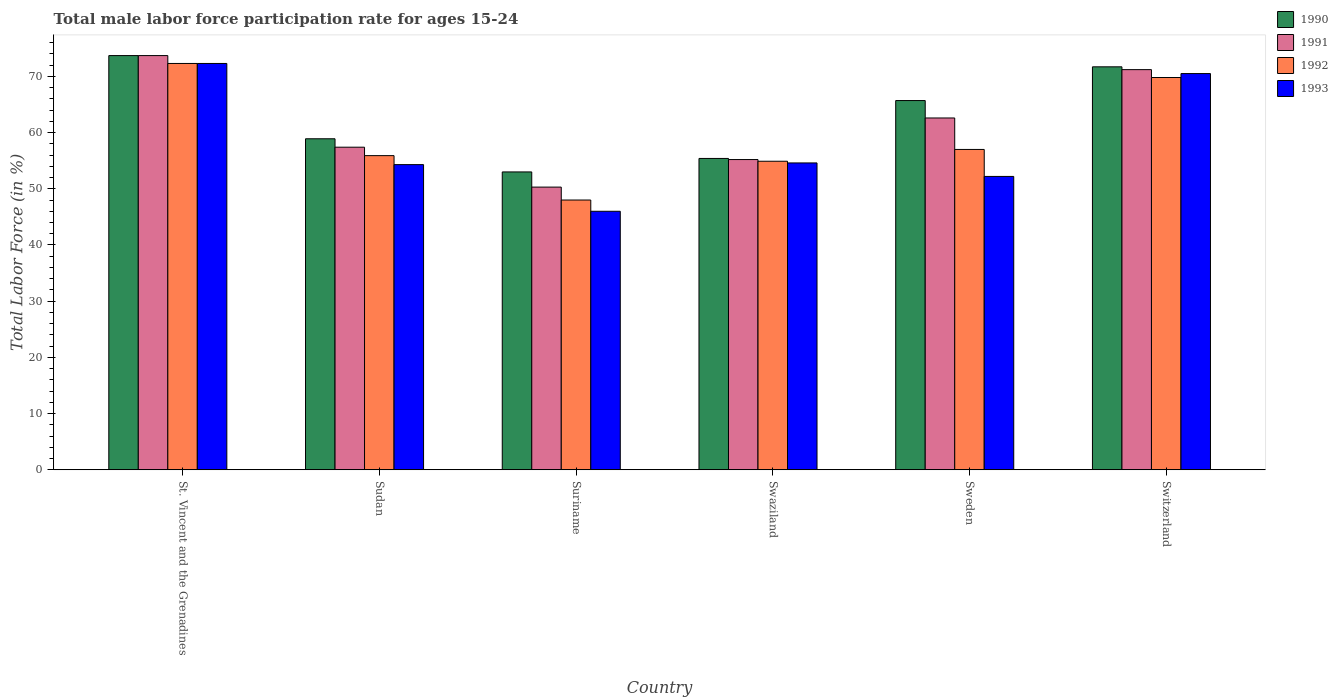Are the number of bars on each tick of the X-axis equal?
Your answer should be very brief. Yes. How many bars are there on the 4th tick from the right?
Your answer should be very brief. 4. What is the label of the 5th group of bars from the left?
Your response must be concise. Sweden. In how many cases, is the number of bars for a given country not equal to the number of legend labels?
Your answer should be compact. 0. What is the male labor force participation rate in 1991 in Switzerland?
Give a very brief answer. 71.2. Across all countries, what is the maximum male labor force participation rate in 1992?
Keep it short and to the point. 72.3. Across all countries, what is the minimum male labor force participation rate in 1993?
Ensure brevity in your answer.  46. In which country was the male labor force participation rate in 1991 maximum?
Keep it short and to the point. St. Vincent and the Grenadines. In which country was the male labor force participation rate in 1992 minimum?
Your answer should be very brief. Suriname. What is the total male labor force participation rate in 1993 in the graph?
Provide a short and direct response. 349.9. What is the difference between the male labor force participation rate in 1993 in Suriname and that in Sweden?
Offer a terse response. -6.2. What is the average male labor force participation rate in 1992 per country?
Your answer should be compact. 59.65. What is the difference between the male labor force participation rate of/in 1993 and male labor force participation rate of/in 1990 in Sudan?
Offer a terse response. -4.6. In how many countries, is the male labor force participation rate in 1991 greater than 56 %?
Give a very brief answer. 4. What is the ratio of the male labor force participation rate in 1990 in Suriname to that in Sweden?
Your answer should be very brief. 0.81. What is the difference between the highest and the lowest male labor force participation rate in 1991?
Your answer should be compact. 23.4. In how many countries, is the male labor force participation rate in 1991 greater than the average male labor force participation rate in 1991 taken over all countries?
Give a very brief answer. 3. Is the sum of the male labor force participation rate in 1991 in Sudan and Suriname greater than the maximum male labor force participation rate in 1990 across all countries?
Keep it short and to the point. Yes. What does the 4th bar from the left in Sweden represents?
Offer a very short reply. 1993. How many bars are there?
Offer a terse response. 24. How many countries are there in the graph?
Offer a terse response. 6. What is the difference between two consecutive major ticks on the Y-axis?
Give a very brief answer. 10. Are the values on the major ticks of Y-axis written in scientific E-notation?
Make the answer very short. No. Where does the legend appear in the graph?
Offer a terse response. Top right. What is the title of the graph?
Your answer should be compact. Total male labor force participation rate for ages 15-24. What is the Total Labor Force (in %) of 1990 in St. Vincent and the Grenadines?
Give a very brief answer. 73.7. What is the Total Labor Force (in %) of 1991 in St. Vincent and the Grenadines?
Your answer should be compact. 73.7. What is the Total Labor Force (in %) of 1992 in St. Vincent and the Grenadines?
Provide a succinct answer. 72.3. What is the Total Labor Force (in %) in 1993 in St. Vincent and the Grenadines?
Provide a succinct answer. 72.3. What is the Total Labor Force (in %) of 1990 in Sudan?
Provide a succinct answer. 58.9. What is the Total Labor Force (in %) of 1991 in Sudan?
Offer a very short reply. 57.4. What is the Total Labor Force (in %) in 1992 in Sudan?
Your response must be concise. 55.9. What is the Total Labor Force (in %) of 1993 in Sudan?
Your answer should be compact. 54.3. What is the Total Labor Force (in %) in 1991 in Suriname?
Your response must be concise. 50.3. What is the Total Labor Force (in %) of 1993 in Suriname?
Provide a succinct answer. 46. What is the Total Labor Force (in %) of 1990 in Swaziland?
Keep it short and to the point. 55.4. What is the Total Labor Force (in %) in 1991 in Swaziland?
Give a very brief answer. 55.2. What is the Total Labor Force (in %) in 1992 in Swaziland?
Make the answer very short. 54.9. What is the Total Labor Force (in %) in 1993 in Swaziland?
Your answer should be very brief. 54.6. What is the Total Labor Force (in %) in 1990 in Sweden?
Your answer should be compact. 65.7. What is the Total Labor Force (in %) of 1991 in Sweden?
Your answer should be compact. 62.6. What is the Total Labor Force (in %) in 1993 in Sweden?
Your answer should be very brief. 52.2. What is the Total Labor Force (in %) in 1990 in Switzerland?
Provide a succinct answer. 71.7. What is the Total Labor Force (in %) of 1991 in Switzerland?
Offer a terse response. 71.2. What is the Total Labor Force (in %) in 1992 in Switzerland?
Your response must be concise. 69.8. What is the Total Labor Force (in %) of 1993 in Switzerland?
Your answer should be compact. 70.5. Across all countries, what is the maximum Total Labor Force (in %) of 1990?
Ensure brevity in your answer.  73.7. Across all countries, what is the maximum Total Labor Force (in %) in 1991?
Offer a very short reply. 73.7. Across all countries, what is the maximum Total Labor Force (in %) in 1992?
Keep it short and to the point. 72.3. Across all countries, what is the maximum Total Labor Force (in %) of 1993?
Ensure brevity in your answer.  72.3. Across all countries, what is the minimum Total Labor Force (in %) in 1990?
Keep it short and to the point. 53. Across all countries, what is the minimum Total Labor Force (in %) in 1991?
Your answer should be compact. 50.3. What is the total Total Labor Force (in %) of 1990 in the graph?
Keep it short and to the point. 378.4. What is the total Total Labor Force (in %) in 1991 in the graph?
Your answer should be compact. 370.4. What is the total Total Labor Force (in %) in 1992 in the graph?
Give a very brief answer. 357.9. What is the total Total Labor Force (in %) of 1993 in the graph?
Give a very brief answer. 349.9. What is the difference between the Total Labor Force (in %) in 1990 in St. Vincent and the Grenadines and that in Sudan?
Make the answer very short. 14.8. What is the difference between the Total Labor Force (in %) in 1992 in St. Vincent and the Grenadines and that in Sudan?
Your answer should be very brief. 16.4. What is the difference between the Total Labor Force (in %) in 1990 in St. Vincent and the Grenadines and that in Suriname?
Provide a short and direct response. 20.7. What is the difference between the Total Labor Force (in %) in 1991 in St. Vincent and the Grenadines and that in Suriname?
Offer a very short reply. 23.4. What is the difference between the Total Labor Force (in %) of 1992 in St. Vincent and the Grenadines and that in Suriname?
Provide a succinct answer. 24.3. What is the difference between the Total Labor Force (in %) in 1993 in St. Vincent and the Grenadines and that in Suriname?
Ensure brevity in your answer.  26.3. What is the difference between the Total Labor Force (in %) in 1991 in St. Vincent and the Grenadines and that in Swaziland?
Provide a short and direct response. 18.5. What is the difference between the Total Labor Force (in %) of 1992 in St. Vincent and the Grenadines and that in Swaziland?
Keep it short and to the point. 17.4. What is the difference between the Total Labor Force (in %) in 1993 in St. Vincent and the Grenadines and that in Sweden?
Your answer should be very brief. 20.1. What is the difference between the Total Labor Force (in %) of 1991 in St. Vincent and the Grenadines and that in Switzerland?
Offer a terse response. 2.5. What is the difference between the Total Labor Force (in %) of 1992 in St. Vincent and the Grenadines and that in Switzerland?
Offer a terse response. 2.5. What is the difference between the Total Labor Force (in %) of 1991 in Sudan and that in Suriname?
Offer a terse response. 7.1. What is the difference between the Total Labor Force (in %) of 1993 in Sudan and that in Suriname?
Give a very brief answer. 8.3. What is the difference between the Total Labor Force (in %) in 1991 in Sudan and that in Swaziland?
Give a very brief answer. 2.2. What is the difference between the Total Labor Force (in %) of 1990 in Sudan and that in Sweden?
Offer a terse response. -6.8. What is the difference between the Total Labor Force (in %) of 1992 in Sudan and that in Sweden?
Ensure brevity in your answer.  -1.1. What is the difference between the Total Labor Force (in %) of 1993 in Sudan and that in Sweden?
Give a very brief answer. 2.1. What is the difference between the Total Labor Force (in %) in 1992 in Sudan and that in Switzerland?
Provide a succinct answer. -13.9. What is the difference between the Total Labor Force (in %) of 1993 in Sudan and that in Switzerland?
Provide a succinct answer. -16.2. What is the difference between the Total Labor Force (in %) in 1990 in Suriname and that in Swaziland?
Offer a terse response. -2.4. What is the difference between the Total Labor Force (in %) in 1992 in Suriname and that in Swaziland?
Your answer should be very brief. -6.9. What is the difference between the Total Labor Force (in %) of 1990 in Suriname and that in Sweden?
Ensure brevity in your answer.  -12.7. What is the difference between the Total Labor Force (in %) of 1992 in Suriname and that in Sweden?
Give a very brief answer. -9. What is the difference between the Total Labor Force (in %) in 1993 in Suriname and that in Sweden?
Keep it short and to the point. -6.2. What is the difference between the Total Labor Force (in %) of 1990 in Suriname and that in Switzerland?
Provide a succinct answer. -18.7. What is the difference between the Total Labor Force (in %) of 1991 in Suriname and that in Switzerland?
Provide a succinct answer. -20.9. What is the difference between the Total Labor Force (in %) in 1992 in Suriname and that in Switzerland?
Provide a succinct answer. -21.8. What is the difference between the Total Labor Force (in %) of 1993 in Suriname and that in Switzerland?
Offer a very short reply. -24.5. What is the difference between the Total Labor Force (in %) in 1992 in Swaziland and that in Sweden?
Give a very brief answer. -2.1. What is the difference between the Total Labor Force (in %) in 1990 in Swaziland and that in Switzerland?
Make the answer very short. -16.3. What is the difference between the Total Labor Force (in %) in 1991 in Swaziland and that in Switzerland?
Your response must be concise. -16. What is the difference between the Total Labor Force (in %) in 1992 in Swaziland and that in Switzerland?
Offer a very short reply. -14.9. What is the difference between the Total Labor Force (in %) in 1993 in Swaziland and that in Switzerland?
Ensure brevity in your answer.  -15.9. What is the difference between the Total Labor Force (in %) in 1991 in Sweden and that in Switzerland?
Offer a very short reply. -8.6. What is the difference between the Total Labor Force (in %) of 1993 in Sweden and that in Switzerland?
Ensure brevity in your answer.  -18.3. What is the difference between the Total Labor Force (in %) of 1992 in St. Vincent and the Grenadines and the Total Labor Force (in %) of 1993 in Sudan?
Make the answer very short. 18. What is the difference between the Total Labor Force (in %) of 1990 in St. Vincent and the Grenadines and the Total Labor Force (in %) of 1991 in Suriname?
Provide a short and direct response. 23.4. What is the difference between the Total Labor Force (in %) in 1990 in St. Vincent and the Grenadines and the Total Labor Force (in %) in 1992 in Suriname?
Give a very brief answer. 25.7. What is the difference between the Total Labor Force (in %) in 1990 in St. Vincent and the Grenadines and the Total Labor Force (in %) in 1993 in Suriname?
Offer a very short reply. 27.7. What is the difference between the Total Labor Force (in %) in 1991 in St. Vincent and the Grenadines and the Total Labor Force (in %) in 1992 in Suriname?
Ensure brevity in your answer.  25.7. What is the difference between the Total Labor Force (in %) of 1991 in St. Vincent and the Grenadines and the Total Labor Force (in %) of 1993 in Suriname?
Provide a short and direct response. 27.7. What is the difference between the Total Labor Force (in %) in 1992 in St. Vincent and the Grenadines and the Total Labor Force (in %) in 1993 in Suriname?
Make the answer very short. 26.3. What is the difference between the Total Labor Force (in %) of 1990 in St. Vincent and the Grenadines and the Total Labor Force (in %) of 1992 in Sweden?
Your response must be concise. 16.7. What is the difference between the Total Labor Force (in %) of 1992 in St. Vincent and the Grenadines and the Total Labor Force (in %) of 1993 in Sweden?
Make the answer very short. 20.1. What is the difference between the Total Labor Force (in %) of 1990 in St. Vincent and the Grenadines and the Total Labor Force (in %) of 1991 in Switzerland?
Your answer should be very brief. 2.5. What is the difference between the Total Labor Force (in %) in 1991 in St. Vincent and the Grenadines and the Total Labor Force (in %) in 1993 in Switzerland?
Your answer should be very brief. 3.2. What is the difference between the Total Labor Force (in %) of 1990 in Sudan and the Total Labor Force (in %) of 1991 in Suriname?
Your response must be concise. 8.6. What is the difference between the Total Labor Force (in %) of 1991 in Sudan and the Total Labor Force (in %) of 1993 in Suriname?
Your response must be concise. 11.4. What is the difference between the Total Labor Force (in %) in 1990 in Sudan and the Total Labor Force (in %) in 1991 in Swaziland?
Your response must be concise. 3.7. What is the difference between the Total Labor Force (in %) of 1990 in Sudan and the Total Labor Force (in %) of 1993 in Swaziland?
Provide a short and direct response. 4.3. What is the difference between the Total Labor Force (in %) in 1991 in Sudan and the Total Labor Force (in %) in 1993 in Swaziland?
Offer a very short reply. 2.8. What is the difference between the Total Labor Force (in %) of 1992 in Sudan and the Total Labor Force (in %) of 1993 in Swaziland?
Your answer should be very brief. 1.3. What is the difference between the Total Labor Force (in %) in 1990 in Sudan and the Total Labor Force (in %) in 1991 in Switzerland?
Offer a very short reply. -12.3. What is the difference between the Total Labor Force (in %) of 1990 in Sudan and the Total Labor Force (in %) of 1993 in Switzerland?
Offer a terse response. -11.6. What is the difference between the Total Labor Force (in %) of 1991 in Sudan and the Total Labor Force (in %) of 1992 in Switzerland?
Make the answer very short. -12.4. What is the difference between the Total Labor Force (in %) in 1991 in Sudan and the Total Labor Force (in %) in 1993 in Switzerland?
Offer a terse response. -13.1. What is the difference between the Total Labor Force (in %) in 1992 in Sudan and the Total Labor Force (in %) in 1993 in Switzerland?
Offer a very short reply. -14.6. What is the difference between the Total Labor Force (in %) of 1990 in Suriname and the Total Labor Force (in %) of 1991 in Swaziland?
Offer a terse response. -2.2. What is the difference between the Total Labor Force (in %) in 1990 in Suriname and the Total Labor Force (in %) in 1992 in Swaziland?
Provide a succinct answer. -1.9. What is the difference between the Total Labor Force (in %) in 1990 in Suriname and the Total Labor Force (in %) in 1993 in Swaziland?
Your answer should be compact. -1.6. What is the difference between the Total Labor Force (in %) of 1991 in Suriname and the Total Labor Force (in %) of 1992 in Swaziland?
Offer a very short reply. -4.6. What is the difference between the Total Labor Force (in %) in 1991 in Suriname and the Total Labor Force (in %) in 1993 in Swaziland?
Keep it short and to the point. -4.3. What is the difference between the Total Labor Force (in %) in 1990 in Suriname and the Total Labor Force (in %) in 1991 in Sweden?
Provide a succinct answer. -9.6. What is the difference between the Total Labor Force (in %) of 1990 in Suriname and the Total Labor Force (in %) of 1993 in Sweden?
Offer a very short reply. 0.8. What is the difference between the Total Labor Force (in %) in 1991 in Suriname and the Total Labor Force (in %) in 1993 in Sweden?
Your answer should be very brief. -1.9. What is the difference between the Total Labor Force (in %) of 1990 in Suriname and the Total Labor Force (in %) of 1991 in Switzerland?
Your answer should be very brief. -18.2. What is the difference between the Total Labor Force (in %) in 1990 in Suriname and the Total Labor Force (in %) in 1992 in Switzerland?
Your answer should be very brief. -16.8. What is the difference between the Total Labor Force (in %) of 1990 in Suriname and the Total Labor Force (in %) of 1993 in Switzerland?
Your answer should be very brief. -17.5. What is the difference between the Total Labor Force (in %) in 1991 in Suriname and the Total Labor Force (in %) in 1992 in Switzerland?
Your answer should be compact. -19.5. What is the difference between the Total Labor Force (in %) of 1991 in Suriname and the Total Labor Force (in %) of 1993 in Switzerland?
Offer a very short reply. -20.2. What is the difference between the Total Labor Force (in %) of 1992 in Suriname and the Total Labor Force (in %) of 1993 in Switzerland?
Provide a succinct answer. -22.5. What is the difference between the Total Labor Force (in %) in 1990 in Swaziland and the Total Labor Force (in %) in 1991 in Sweden?
Your answer should be very brief. -7.2. What is the difference between the Total Labor Force (in %) in 1990 in Swaziland and the Total Labor Force (in %) in 1993 in Sweden?
Make the answer very short. 3.2. What is the difference between the Total Labor Force (in %) in 1991 in Swaziland and the Total Labor Force (in %) in 1992 in Sweden?
Provide a short and direct response. -1.8. What is the difference between the Total Labor Force (in %) in 1991 in Swaziland and the Total Labor Force (in %) in 1993 in Sweden?
Keep it short and to the point. 3. What is the difference between the Total Labor Force (in %) in 1990 in Swaziland and the Total Labor Force (in %) in 1991 in Switzerland?
Your response must be concise. -15.8. What is the difference between the Total Labor Force (in %) in 1990 in Swaziland and the Total Labor Force (in %) in 1992 in Switzerland?
Your answer should be very brief. -14.4. What is the difference between the Total Labor Force (in %) of 1990 in Swaziland and the Total Labor Force (in %) of 1993 in Switzerland?
Offer a terse response. -15.1. What is the difference between the Total Labor Force (in %) in 1991 in Swaziland and the Total Labor Force (in %) in 1992 in Switzerland?
Keep it short and to the point. -14.6. What is the difference between the Total Labor Force (in %) in 1991 in Swaziland and the Total Labor Force (in %) in 1993 in Switzerland?
Provide a succinct answer. -15.3. What is the difference between the Total Labor Force (in %) of 1992 in Swaziland and the Total Labor Force (in %) of 1993 in Switzerland?
Offer a terse response. -15.6. What is the difference between the Total Labor Force (in %) of 1990 in Sweden and the Total Labor Force (in %) of 1991 in Switzerland?
Make the answer very short. -5.5. What is the difference between the Total Labor Force (in %) of 1990 in Sweden and the Total Labor Force (in %) of 1993 in Switzerland?
Offer a very short reply. -4.8. What is the difference between the Total Labor Force (in %) of 1991 in Sweden and the Total Labor Force (in %) of 1993 in Switzerland?
Give a very brief answer. -7.9. What is the average Total Labor Force (in %) in 1990 per country?
Ensure brevity in your answer.  63.07. What is the average Total Labor Force (in %) of 1991 per country?
Offer a terse response. 61.73. What is the average Total Labor Force (in %) of 1992 per country?
Provide a succinct answer. 59.65. What is the average Total Labor Force (in %) of 1993 per country?
Offer a very short reply. 58.32. What is the difference between the Total Labor Force (in %) of 1990 and Total Labor Force (in %) of 1991 in St. Vincent and the Grenadines?
Provide a succinct answer. 0. What is the difference between the Total Labor Force (in %) of 1990 and Total Labor Force (in %) of 1992 in St. Vincent and the Grenadines?
Give a very brief answer. 1.4. What is the difference between the Total Labor Force (in %) in 1990 and Total Labor Force (in %) in 1993 in St. Vincent and the Grenadines?
Your answer should be very brief. 1.4. What is the difference between the Total Labor Force (in %) in 1991 and Total Labor Force (in %) in 1993 in St. Vincent and the Grenadines?
Provide a short and direct response. 1.4. What is the difference between the Total Labor Force (in %) of 1992 and Total Labor Force (in %) of 1993 in St. Vincent and the Grenadines?
Offer a very short reply. 0. What is the difference between the Total Labor Force (in %) of 1990 and Total Labor Force (in %) of 1991 in Suriname?
Make the answer very short. 2.7. What is the difference between the Total Labor Force (in %) in 1990 and Total Labor Force (in %) in 1993 in Suriname?
Offer a very short reply. 7. What is the difference between the Total Labor Force (in %) of 1991 and Total Labor Force (in %) of 1992 in Suriname?
Keep it short and to the point. 2.3. What is the difference between the Total Labor Force (in %) of 1992 and Total Labor Force (in %) of 1993 in Suriname?
Offer a terse response. 2. What is the difference between the Total Labor Force (in %) in 1990 and Total Labor Force (in %) in 1993 in Swaziland?
Ensure brevity in your answer.  0.8. What is the difference between the Total Labor Force (in %) of 1991 and Total Labor Force (in %) of 1992 in Swaziland?
Give a very brief answer. 0.3. What is the difference between the Total Labor Force (in %) of 1992 and Total Labor Force (in %) of 1993 in Swaziland?
Your answer should be compact. 0.3. What is the difference between the Total Labor Force (in %) in 1990 and Total Labor Force (in %) in 1991 in Sweden?
Your answer should be compact. 3.1. What is the difference between the Total Labor Force (in %) of 1990 and Total Labor Force (in %) of 1993 in Sweden?
Provide a short and direct response. 13.5. What is the difference between the Total Labor Force (in %) of 1991 and Total Labor Force (in %) of 1992 in Sweden?
Your answer should be very brief. 5.6. What is the difference between the Total Labor Force (in %) of 1990 and Total Labor Force (in %) of 1993 in Switzerland?
Provide a short and direct response. 1.2. What is the difference between the Total Labor Force (in %) of 1991 and Total Labor Force (in %) of 1992 in Switzerland?
Offer a terse response. 1.4. What is the ratio of the Total Labor Force (in %) of 1990 in St. Vincent and the Grenadines to that in Sudan?
Your response must be concise. 1.25. What is the ratio of the Total Labor Force (in %) in 1991 in St. Vincent and the Grenadines to that in Sudan?
Keep it short and to the point. 1.28. What is the ratio of the Total Labor Force (in %) in 1992 in St. Vincent and the Grenadines to that in Sudan?
Give a very brief answer. 1.29. What is the ratio of the Total Labor Force (in %) of 1993 in St. Vincent and the Grenadines to that in Sudan?
Provide a succinct answer. 1.33. What is the ratio of the Total Labor Force (in %) in 1990 in St. Vincent and the Grenadines to that in Suriname?
Keep it short and to the point. 1.39. What is the ratio of the Total Labor Force (in %) in 1991 in St. Vincent and the Grenadines to that in Suriname?
Your response must be concise. 1.47. What is the ratio of the Total Labor Force (in %) of 1992 in St. Vincent and the Grenadines to that in Suriname?
Keep it short and to the point. 1.51. What is the ratio of the Total Labor Force (in %) in 1993 in St. Vincent and the Grenadines to that in Suriname?
Provide a succinct answer. 1.57. What is the ratio of the Total Labor Force (in %) of 1990 in St. Vincent and the Grenadines to that in Swaziland?
Ensure brevity in your answer.  1.33. What is the ratio of the Total Labor Force (in %) in 1991 in St. Vincent and the Grenadines to that in Swaziland?
Keep it short and to the point. 1.34. What is the ratio of the Total Labor Force (in %) of 1992 in St. Vincent and the Grenadines to that in Swaziland?
Your response must be concise. 1.32. What is the ratio of the Total Labor Force (in %) of 1993 in St. Vincent and the Grenadines to that in Swaziland?
Offer a very short reply. 1.32. What is the ratio of the Total Labor Force (in %) of 1990 in St. Vincent and the Grenadines to that in Sweden?
Provide a succinct answer. 1.12. What is the ratio of the Total Labor Force (in %) of 1991 in St. Vincent and the Grenadines to that in Sweden?
Your response must be concise. 1.18. What is the ratio of the Total Labor Force (in %) of 1992 in St. Vincent and the Grenadines to that in Sweden?
Provide a short and direct response. 1.27. What is the ratio of the Total Labor Force (in %) in 1993 in St. Vincent and the Grenadines to that in Sweden?
Provide a short and direct response. 1.39. What is the ratio of the Total Labor Force (in %) in 1990 in St. Vincent and the Grenadines to that in Switzerland?
Your response must be concise. 1.03. What is the ratio of the Total Labor Force (in %) of 1991 in St. Vincent and the Grenadines to that in Switzerland?
Ensure brevity in your answer.  1.04. What is the ratio of the Total Labor Force (in %) in 1992 in St. Vincent and the Grenadines to that in Switzerland?
Ensure brevity in your answer.  1.04. What is the ratio of the Total Labor Force (in %) of 1993 in St. Vincent and the Grenadines to that in Switzerland?
Offer a terse response. 1.03. What is the ratio of the Total Labor Force (in %) in 1990 in Sudan to that in Suriname?
Your answer should be compact. 1.11. What is the ratio of the Total Labor Force (in %) in 1991 in Sudan to that in Suriname?
Your answer should be very brief. 1.14. What is the ratio of the Total Labor Force (in %) in 1992 in Sudan to that in Suriname?
Keep it short and to the point. 1.16. What is the ratio of the Total Labor Force (in %) of 1993 in Sudan to that in Suriname?
Keep it short and to the point. 1.18. What is the ratio of the Total Labor Force (in %) in 1990 in Sudan to that in Swaziland?
Ensure brevity in your answer.  1.06. What is the ratio of the Total Labor Force (in %) of 1991 in Sudan to that in Swaziland?
Offer a terse response. 1.04. What is the ratio of the Total Labor Force (in %) in 1992 in Sudan to that in Swaziland?
Offer a terse response. 1.02. What is the ratio of the Total Labor Force (in %) in 1990 in Sudan to that in Sweden?
Keep it short and to the point. 0.9. What is the ratio of the Total Labor Force (in %) of 1991 in Sudan to that in Sweden?
Make the answer very short. 0.92. What is the ratio of the Total Labor Force (in %) of 1992 in Sudan to that in Sweden?
Your answer should be very brief. 0.98. What is the ratio of the Total Labor Force (in %) in 1993 in Sudan to that in Sweden?
Your response must be concise. 1.04. What is the ratio of the Total Labor Force (in %) of 1990 in Sudan to that in Switzerland?
Provide a succinct answer. 0.82. What is the ratio of the Total Labor Force (in %) in 1991 in Sudan to that in Switzerland?
Your answer should be very brief. 0.81. What is the ratio of the Total Labor Force (in %) in 1992 in Sudan to that in Switzerland?
Offer a very short reply. 0.8. What is the ratio of the Total Labor Force (in %) in 1993 in Sudan to that in Switzerland?
Provide a succinct answer. 0.77. What is the ratio of the Total Labor Force (in %) of 1990 in Suriname to that in Swaziland?
Offer a terse response. 0.96. What is the ratio of the Total Labor Force (in %) in 1991 in Suriname to that in Swaziland?
Make the answer very short. 0.91. What is the ratio of the Total Labor Force (in %) in 1992 in Suriname to that in Swaziland?
Offer a terse response. 0.87. What is the ratio of the Total Labor Force (in %) in 1993 in Suriname to that in Swaziland?
Make the answer very short. 0.84. What is the ratio of the Total Labor Force (in %) of 1990 in Suriname to that in Sweden?
Offer a terse response. 0.81. What is the ratio of the Total Labor Force (in %) of 1991 in Suriname to that in Sweden?
Your answer should be very brief. 0.8. What is the ratio of the Total Labor Force (in %) in 1992 in Suriname to that in Sweden?
Your answer should be compact. 0.84. What is the ratio of the Total Labor Force (in %) in 1993 in Suriname to that in Sweden?
Your response must be concise. 0.88. What is the ratio of the Total Labor Force (in %) of 1990 in Suriname to that in Switzerland?
Ensure brevity in your answer.  0.74. What is the ratio of the Total Labor Force (in %) in 1991 in Suriname to that in Switzerland?
Offer a terse response. 0.71. What is the ratio of the Total Labor Force (in %) in 1992 in Suriname to that in Switzerland?
Make the answer very short. 0.69. What is the ratio of the Total Labor Force (in %) of 1993 in Suriname to that in Switzerland?
Make the answer very short. 0.65. What is the ratio of the Total Labor Force (in %) in 1990 in Swaziland to that in Sweden?
Keep it short and to the point. 0.84. What is the ratio of the Total Labor Force (in %) of 1991 in Swaziland to that in Sweden?
Offer a terse response. 0.88. What is the ratio of the Total Labor Force (in %) of 1992 in Swaziland to that in Sweden?
Keep it short and to the point. 0.96. What is the ratio of the Total Labor Force (in %) of 1993 in Swaziland to that in Sweden?
Your response must be concise. 1.05. What is the ratio of the Total Labor Force (in %) in 1990 in Swaziland to that in Switzerland?
Your answer should be very brief. 0.77. What is the ratio of the Total Labor Force (in %) in 1991 in Swaziland to that in Switzerland?
Ensure brevity in your answer.  0.78. What is the ratio of the Total Labor Force (in %) in 1992 in Swaziland to that in Switzerland?
Offer a very short reply. 0.79. What is the ratio of the Total Labor Force (in %) in 1993 in Swaziland to that in Switzerland?
Keep it short and to the point. 0.77. What is the ratio of the Total Labor Force (in %) in 1990 in Sweden to that in Switzerland?
Your response must be concise. 0.92. What is the ratio of the Total Labor Force (in %) of 1991 in Sweden to that in Switzerland?
Make the answer very short. 0.88. What is the ratio of the Total Labor Force (in %) in 1992 in Sweden to that in Switzerland?
Your answer should be very brief. 0.82. What is the ratio of the Total Labor Force (in %) in 1993 in Sweden to that in Switzerland?
Give a very brief answer. 0.74. What is the difference between the highest and the second highest Total Labor Force (in %) of 1991?
Your response must be concise. 2.5. What is the difference between the highest and the second highest Total Labor Force (in %) of 1992?
Offer a very short reply. 2.5. What is the difference between the highest and the lowest Total Labor Force (in %) of 1990?
Offer a very short reply. 20.7. What is the difference between the highest and the lowest Total Labor Force (in %) in 1991?
Offer a very short reply. 23.4. What is the difference between the highest and the lowest Total Labor Force (in %) of 1992?
Make the answer very short. 24.3. What is the difference between the highest and the lowest Total Labor Force (in %) in 1993?
Your response must be concise. 26.3. 